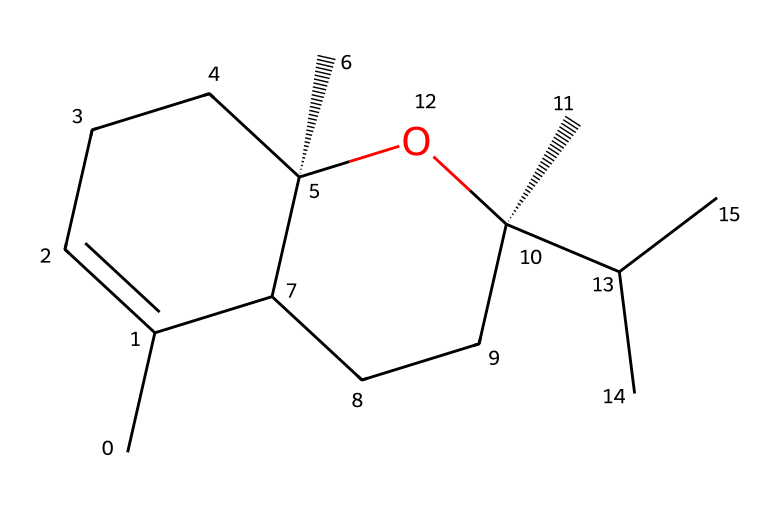What is the name of the chemical represented by this SMILES? Analyzing the SMILES, it describes a specific terpene. The chemical is consistently recognized as caryophyllene, known for its distinct spicy aroma.
Answer: caryophyllene How many carbon atoms are present in caryophyllene? Counting the "C" in the SMILES notation, caryophyllene has a total of fifteen carbon atoms in its structure.
Answer: fifteen What is the number of double bonds in caryophyllene? Examining the structure from the SMILES, there are two instances where double bonds are indicated between carbon atoms, showing there are two double bonds in the molecule.
Answer: two What functional group does caryophyllene contain? Upon reviewing the SMILES representation, we can locate an -OH group, which denotes the presence of an alcohol functional group in caryophyllene.
Answer: alcohol What type of chemical is caryophyllene classified as? Given that caryophyllene belongs to the class of terpenes, which are derived from plant materials and characterized by their specific hydrocarbon structures, we classify it accordingly.
Answer: terpene How does the molecular arrangement indicate its potential use in cleaning solutions? The branched structure and presence of the alcohol functional group suggest that caryophyllene can dissolve oils and residues, enhancing its efficacy in cleaning solutions specifically designed for collectibles.
Answer: oil-dissolving 